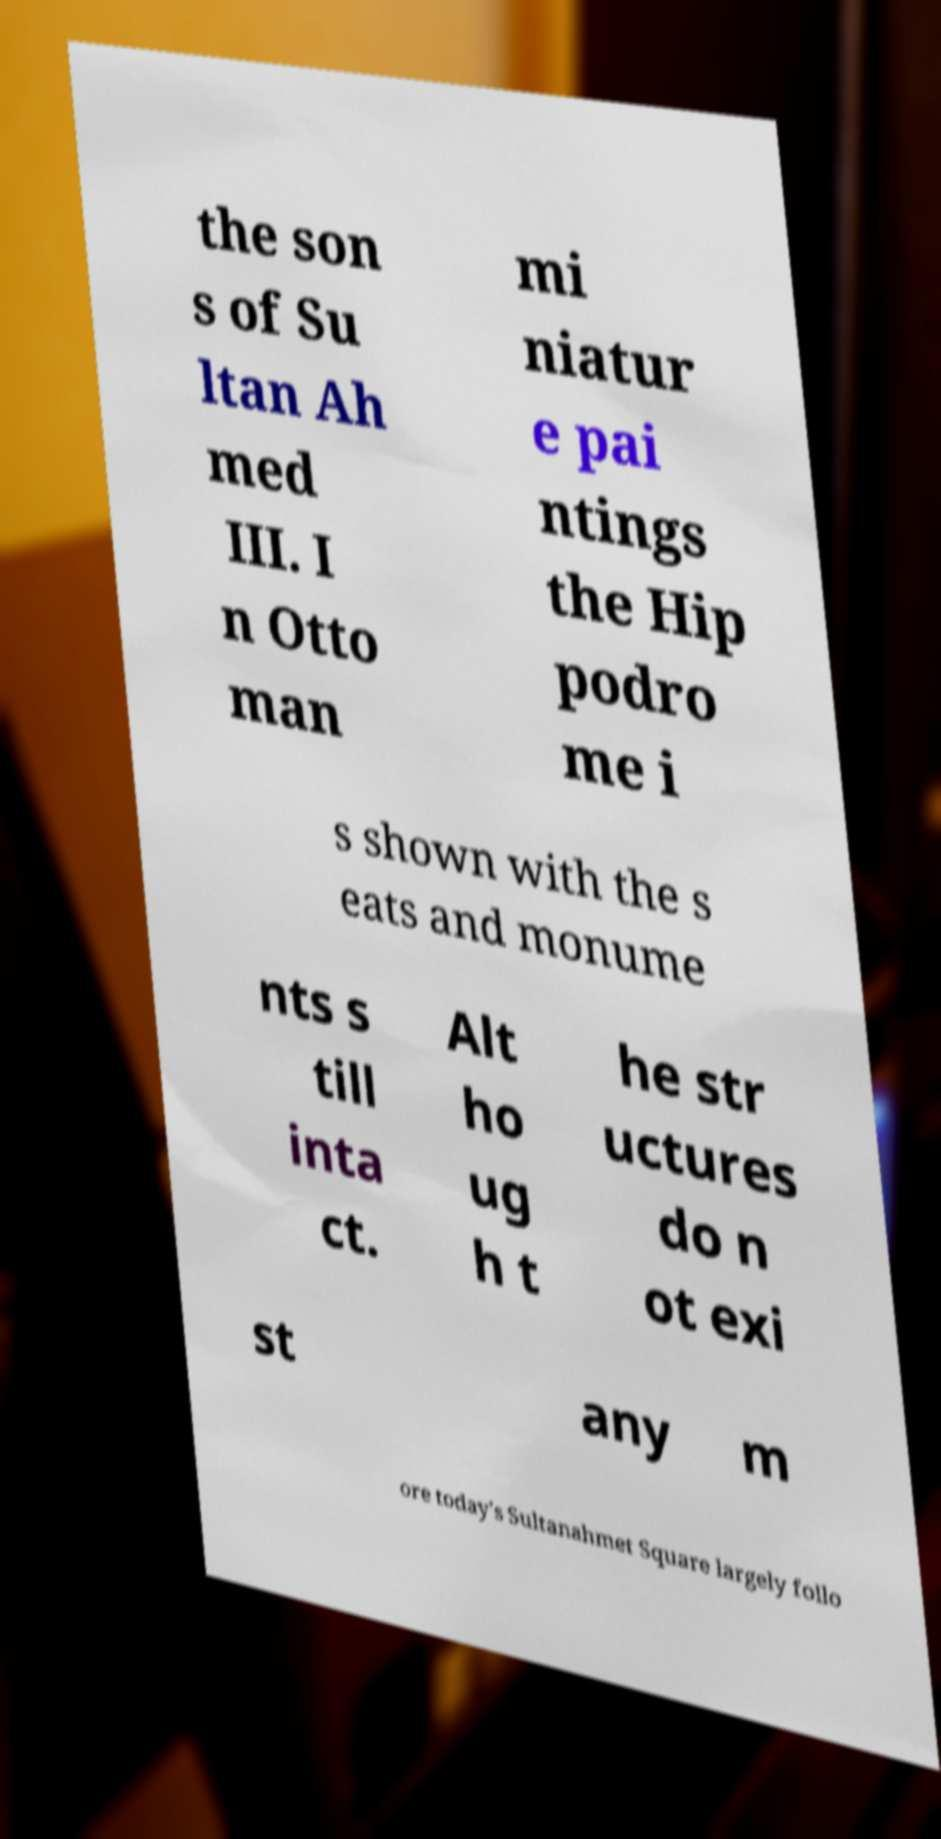Could you extract and type out the text from this image? the son s of Su ltan Ah med III. I n Otto man mi niatur e pai ntings the Hip podro me i s shown with the s eats and monume nts s till inta ct. Alt ho ug h t he str uctures do n ot exi st any m ore today's Sultanahmet Square largely follo 